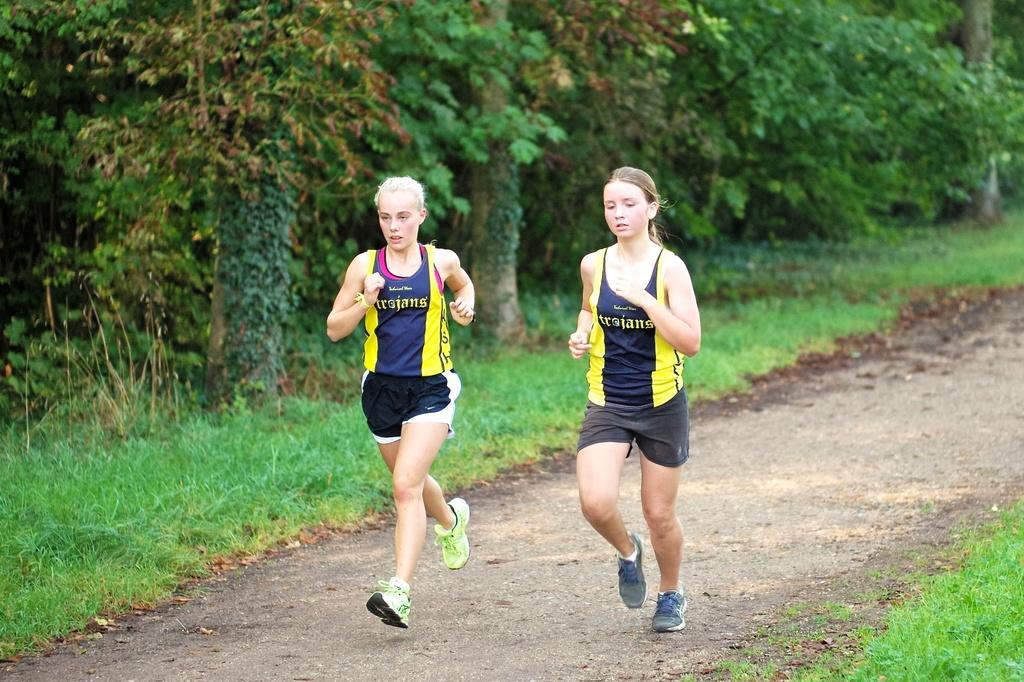Please provide a concise description of this image. In this picture there are two women who are running on the ground. Both of them are wearing same t-shirt, short and shoe. On the left i can see the trees, plants and grass. 